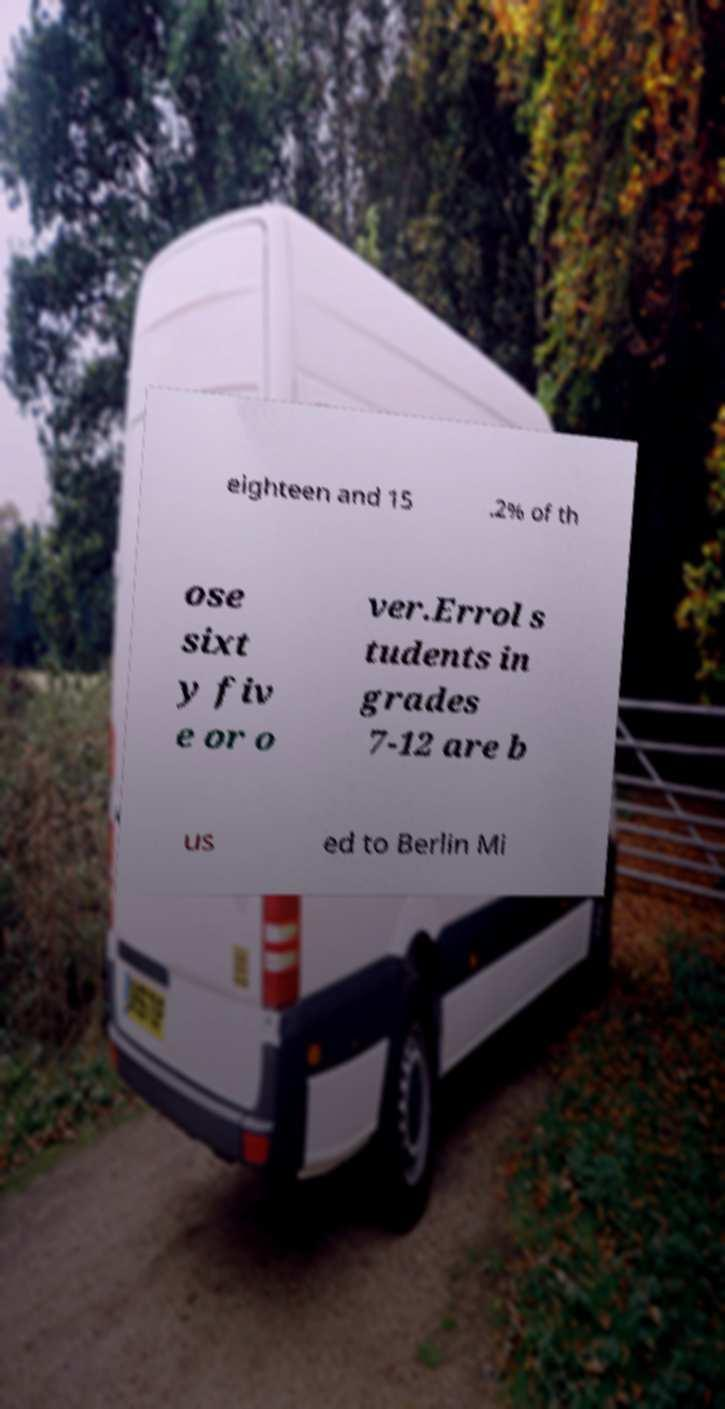Please read and relay the text visible in this image. What does it say? eighteen and 15 .2% of th ose sixt y fiv e or o ver.Errol s tudents in grades 7-12 are b us ed to Berlin Mi 